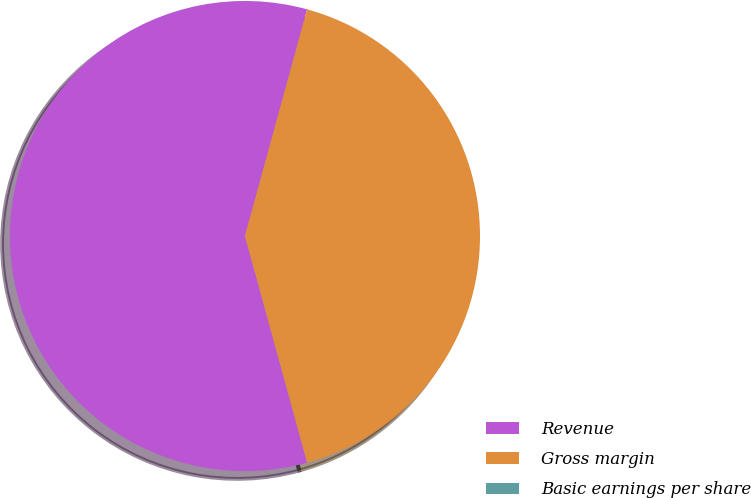<chart> <loc_0><loc_0><loc_500><loc_500><pie_chart><fcel>Revenue<fcel>Gross margin<fcel>Basic earnings per share<nl><fcel>58.52%<fcel>41.48%<fcel>0.0%<nl></chart> 